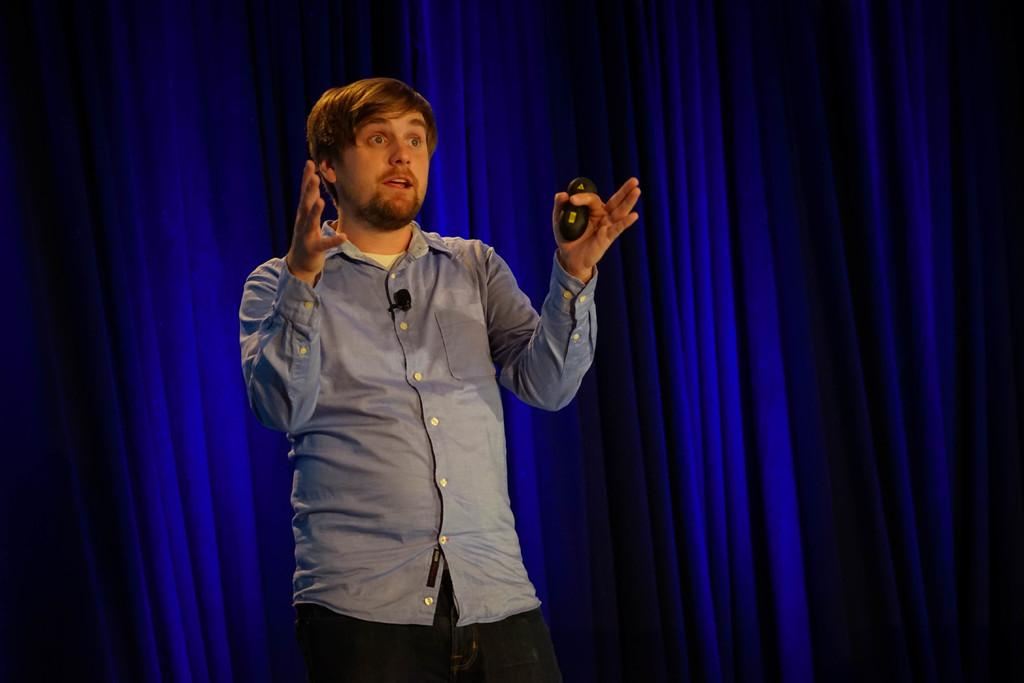What is the person in the image wearing? The person is wearing a blue shirt. What is the person holding in the image? The person is holding an object with one hand. What can be seen on the person's face in the image? The person is wearing a mic. What is the person doing in the image? The person is speaking. Where is the person standing in the image? The person is standing on a stage. What color is the curtain in the background of the image? The curtain in the background is violet. What type of potato is being used as an afterthought in the image? There is no potato present in the image, and the concept of an afterthought is not applicable to the scene depicted. 